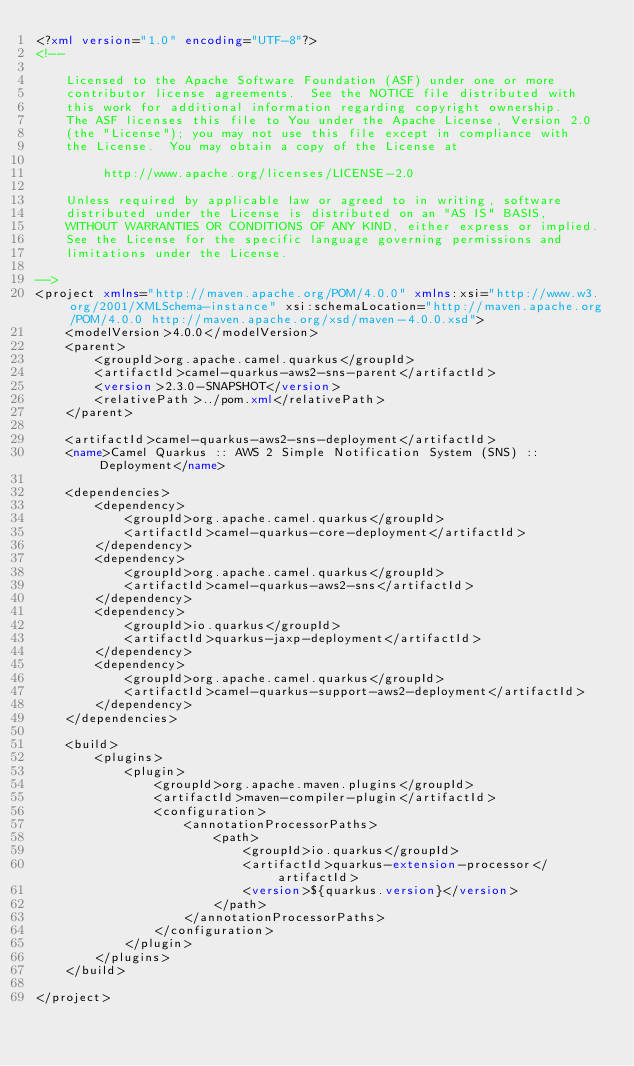Convert code to text. <code><loc_0><loc_0><loc_500><loc_500><_XML_><?xml version="1.0" encoding="UTF-8"?>
<!--

    Licensed to the Apache Software Foundation (ASF) under one or more
    contributor license agreements.  See the NOTICE file distributed with
    this work for additional information regarding copyright ownership.
    The ASF licenses this file to You under the Apache License, Version 2.0
    (the "License"); you may not use this file except in compliance with
    the License.  You may obtain a copy of the License at

         http://www.apache.org/licenses/LICENSE-2.0

    Unless required by applicable law or agreed to in writing, software
    distributed under the License is distributed on an "AS IS" BASIS,
    WITHOUT WARRANTIES OR CONDITIONS OF ANY KIND, either express or implied.
    See the License for the specific language governing permissions and
    limitations under the License.

-->
<project xmlns="http://maven.apache.org/POM/4.0.0" xmlns:xsi="http://www.w3.org/2001/XMLSchema-instance" xsi:schemaLocation="http://maven.apache.org/POM/4.0.0 http://maven.apache.org/xsd/maven-4.0.0.xsd">
    <modelVersion>4.0.0</modelVersion>
    <parent>
        <groupId>org.apache.camel.quarkus</groupId>
        <artifactId>camel-quarkus-aws2-sns-parent</artifactId>
        <version>2.3.0-SNAPSHOT</version>
        <relativePath>../pom.xml</relativePath>
    </parent>

    <artifactId>camel-quarkus-aws2-sns-deployment</artifactId>
    <name>Camel Quarkus :: AWS 2 Simple Notification System (SNS) :: Deployment</name>

    <dependencies>
        <dependency>
            <groupId>org.apache.camel.quarkus</groupId>
            <artifactId>camel-quarkus-core-deployment</artifactId>
        </dependency>
        <dependency>
            <groupId>org.apache.camel.quarkus</groupId>
            <artifactId>camel-quarkus-aws2-sns</artifactId>
        </dependency>
        <dependency>
            <groupId>io.quarkus</groupId>
            <artifactId>quarkus-jaxp-deployment</artifactId>
        </dependency>
        <dependency>
            <groupId>org.apache.camel.quarkus</groupId>
            <artifactId>camel-quarkus-support-aws2-deployment</artifactId>
        </dependency>
    </dependencies>

    <build>
        <plugins>
            <plugin>
                <groupId>org.apache.maven.plugins</groupId>
                <artifactId>maven-compiler-plugin</artifactId>
                <configuration>
                    <annotationProcessorPaths>
                        <path>
                            <groupId>io.quarkus</groupId>
                            <artifactId>quarkus-extension-processor</artifactId>
                            <version>${quarkus.version}</version>
                        </path>
                    </annotationProcessorPaths>
                </configuration>
            </plugin>
        </plugins>
    </build>

</project>
</code> 